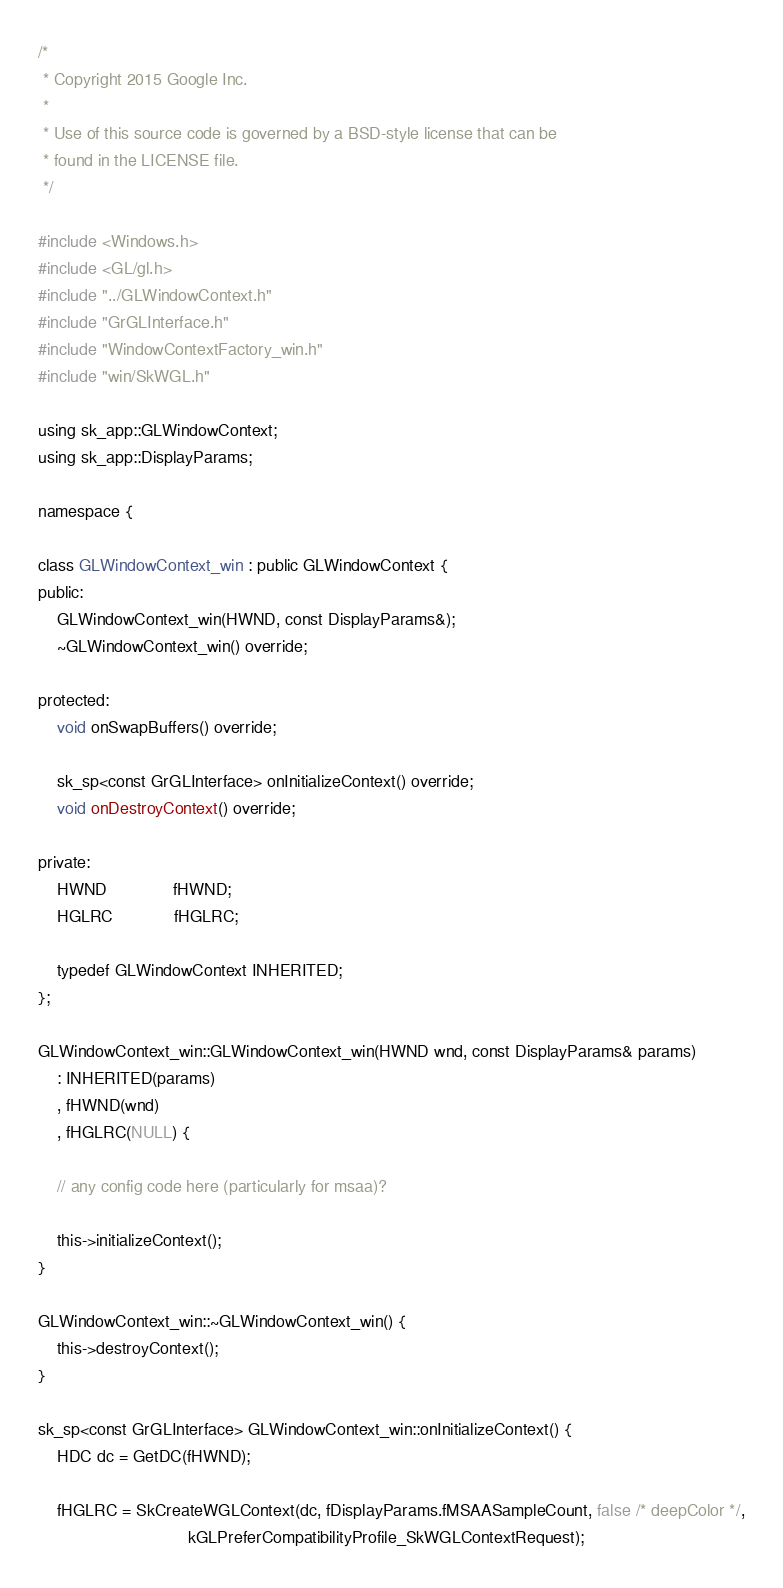<code> <loc_0><loc_0><loc_500><loc_500><_C++_>
/*
 * Copyright 2015 Google Inc.
 *
 * Use of this source code is governed by a BSD-style license that can be
 * found in the LICENSE file.
 */

#include <Windows.h>
#include <GL/gl.h>
#include "../GLWindowContext.h"
#include "GrGLInterface.h"
#include "WindowContextFactory_win.h"
#include "win/SkWGL.h"

using sk_app::GLWindowContext;
using sk_app::DisplayParams;

namespace {

class GLWindowContext_win : public GLWindowContext {
public:
    GLWindowContext_win(HWND, const DisplayParams&);
    ~GLWindowContext_win() override;

protected:
    void onSwapBuffers() override;

    sk_sp<const GrGLInterface> onInitializeContext() override;
    void onDestroyContext() override;

private:
    HWND              fHWND;
    HGLRC             fHGLRC;

    typedef GLWindowContext INHERITED;
};

GLWindowContext_win::GLWindowContext_win(HWND wnd, const DisplayParams& params)
    : INHERITED(params)
    , fHWND(wnd)
    , fHGLRC(NULL) {

    // any config code here (particularly for msaa)?

    this->initializeContext();
}

GLWindowContext_win::~GLWindowContext_win() {
    this->destroyContext();
}

sk_sp<const GrGLInterface> GLWindowContext_win::onInitializeContext() {
    HDC dc = GetDC(fHWND);

    fHGLRC = SkCreateWGLContext(dc, fDisplayParams.fMSAASampleCount, false /* deepColor */,
                                kGLPreferCompatibilityProfile_SkWGLContextRequest);</code> 